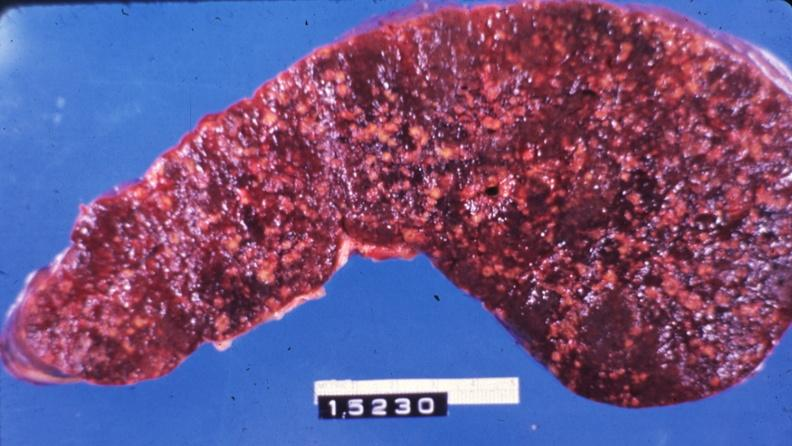s peritoneal fluid present?
Answer the question using a single word or phrase. No 